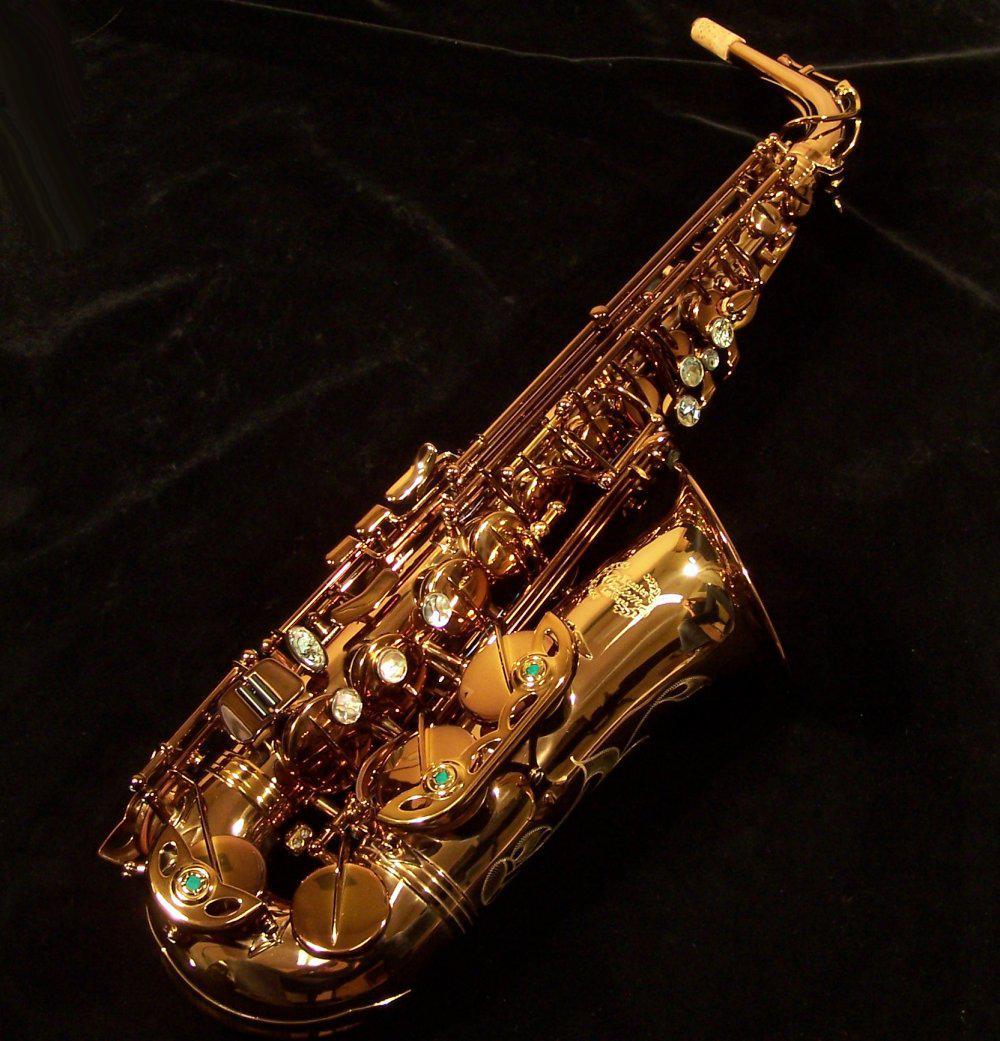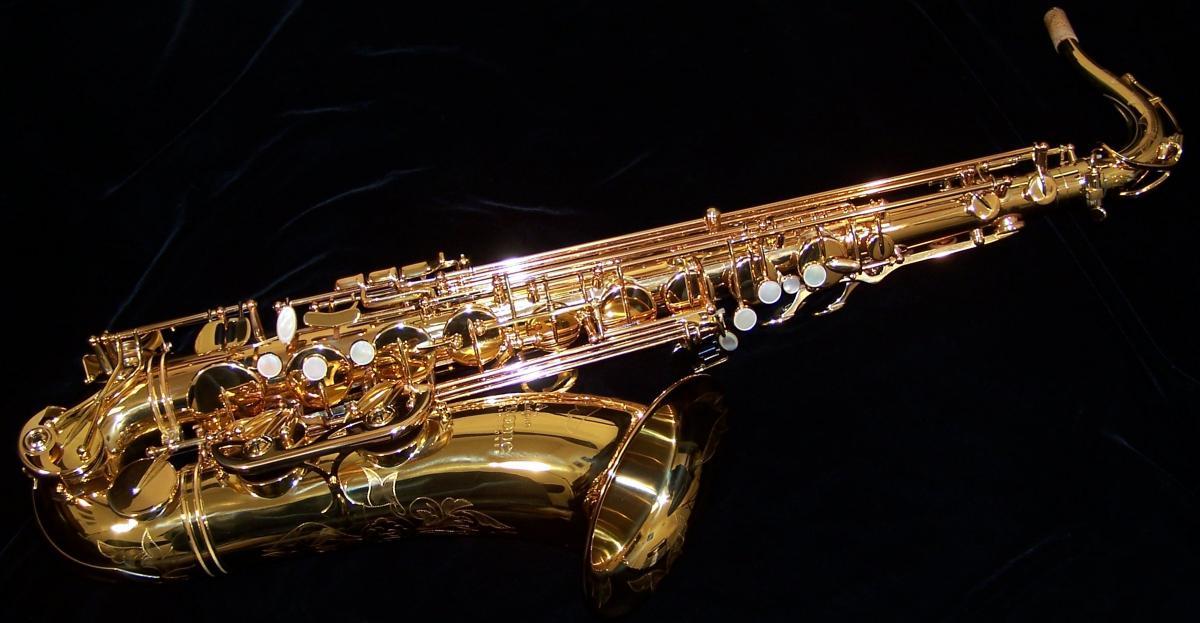The first image is the image on the left, the second image is the image on the right. Evaluate the accuracy of this statement regarding the images: "At least one of the images contains a silver toned saxophone.". Is it true? Answer yes or no. No. The first image is the image on the left, the second image is the image on the right. Given the left and right images, does the statement "The instruments in the left and right images share the same directional position and angle." hold true? Answer yes or no. No. 